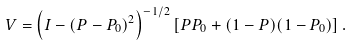<formula> <loc_0><loc_0><loc_500><loc_500>V = \left ( I - ( P - P _ { 0 } ) ^ { 2 } \right ) ^ { - 1 / 2 } \left [ P P _ { 0 } + ( 1 - P ) ( 1 - P _ { 0 } ) \right ] .</formula> 